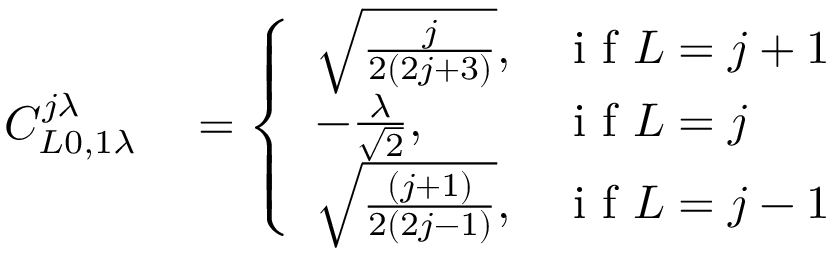<formula> <loc_0><loc_0><loc_500><loc_500>\begin{array} { r l } { C _ { L 0 , 1 \lambda } ^ { j \lambda } } & = \left \{ \begin{array} { l l } { \sqrt { \frac { j } { 2 ( 2 j + 3 ) } } , } & { i f L = j + 1 } \\ { - \frac { \lambda } { \sqrt { 2 } } , } & { i f L = j } \\ { \sqrt { \frac { ( j + 1 ) } { 2 ( 2 j - 1 ) } } , } & { i f L = j - 1 } \end{array} } \end{array}</formula> 